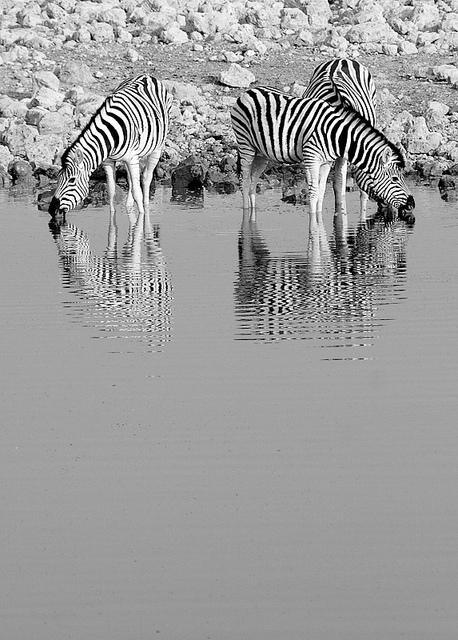What is behind them?
Write a very short answer. Rocks. Are the animals in the zoo?
Write a very short answer. No. What are the zebras doing in the image?
Write a very short answer. Drinking. How many zebras are there?
Write a very short answer. 3. 